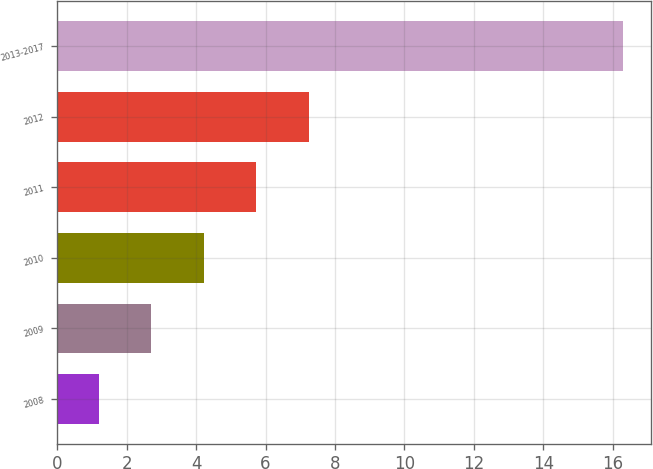<chart> <loc_0><loc_0><loc_500><loc_500><bar_chart><fcel>2008<fcel>2009<fcel>2010<fcel>2011<fcel>2012<fcel>2013-2017<nl><fcel>1.2<fcel>2.71<fcel>4.22<fcel>5.73<fcel>7.24<fcel>16.3<nl></chart> 